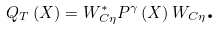Convert formula to latex. <formula><loc_0><loc_0><loc_500><loc_500>Q _ { T } \left ( X \right ) = W _ { C \eta } ^ { \ast } P ^ { \gamma } \left ( X \right ) W _ { C \eta } \text {.}</formula> 